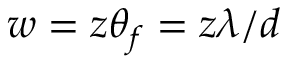<formula> <loc_0><loc_0><loc_500><loc_500>w = z \theta _ { f } = z \lambda / d</formula> 